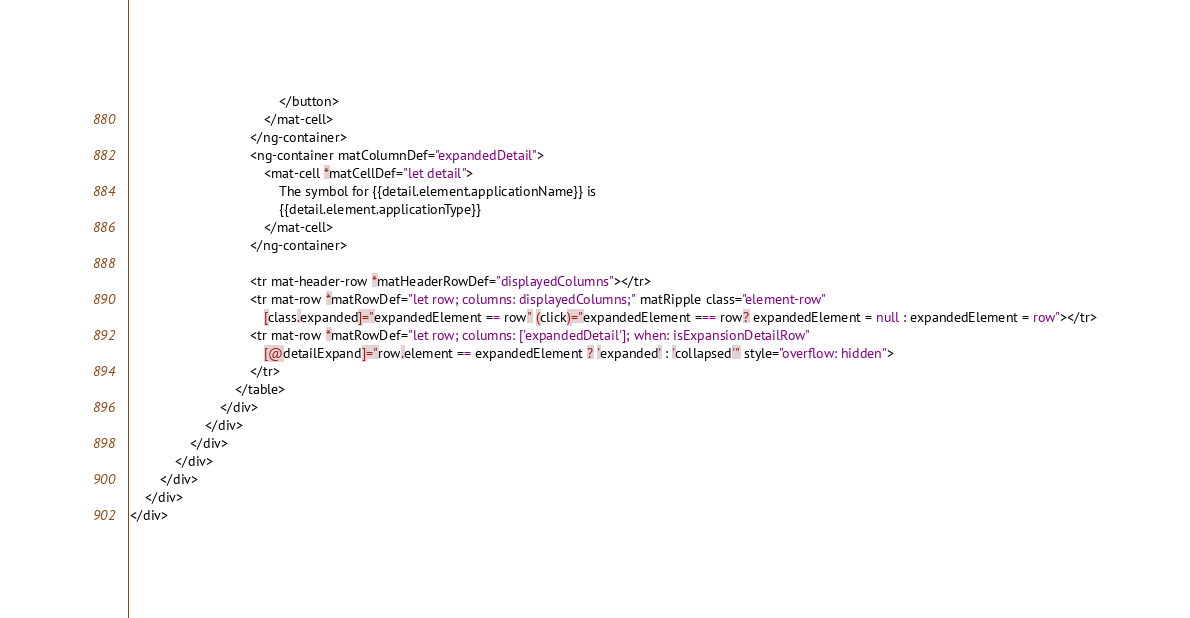<code> <loc_0><loc_0><loc_500><loc_500><_HTML_>                                        </button>
                                    </mat-cell>
                                </ng-container>
                                <ng-container matColumnDef="expandedDetail">
                                    <mat-cell *matCellDef="let detail">
                                        The symbol for {{detail.element.applicationName}} is
                                        {{detail.element.applicationType}}
                                    </mat-cell>
                                </ng-container>

                                <tr mat-header-row *matHeaderRowDef="displayedColumns"></tr>
                                <tr mat-row *matRowDef="let row; columns: displayedColumns;" matRipple class="element-row"
                                    [class.expanded]="expandedElement == row" (click)="expandedElement === row? expandedElement = null : expandedElement = row"></tr>
                                <tr mat-row *matRowDef="let row; columns: ['expandedDetail']; when: isExpansionDetailRow"
                                    [@detailExpand]="row.element == expandedElement ? 'expanded' : 'collapsed'" style="overflow: hidden">
                                </tr>
                            </table>
                        </div>
                    </div>
                </div>
            </div>
        </div>
    </div>
</div></code> 